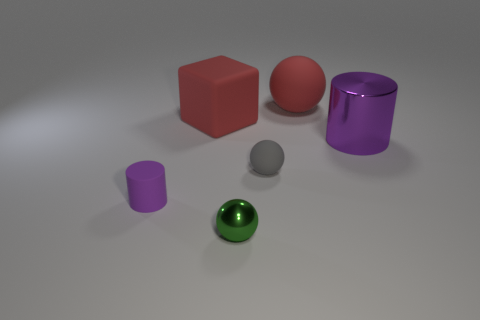Add 1 small things. How many objects exist? 7 Subtract all big matte balls. How many balls are left? 2 Subtract all cubes. How many objects are left? 5 Subtract all green spheres. Subtract all brown cylinders. How many spheres are left? 2 Subtract all green metal objects. Subtract all tiny green objects. How many objects are left? 4 Add 1 tiny purple cylinders. How many tiny purple cylinders are left? 2 Add 2 small blue rubber cylinders. How many small blue rubber cylinders exist? 2 Subtract all red balls. How many balls are left? 2 Subtract 0 brown cylinders. How many objects are left? 6 Subtract 3 spheres. How many spheres are left? 0 